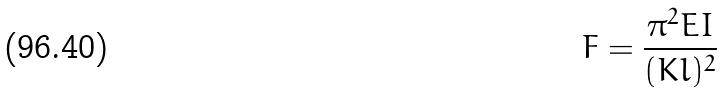<formula> <loc_0><loc_0><loc_500><loc_500>F = \frac { \pi ^ { 2 } E I } { ( K l ) ^ { 2 } }</formula> 